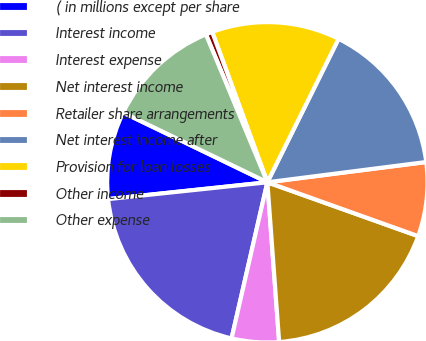Convert chart. <chart><loc_0><loc_0><loc_500><loc_500><pie_chart><fcel>( in millions except per share<fcel>Interest income<fcel>Interest expense<fcel>Net interest income<fcel>Retailer share arrangements<fcel>Net interest income after<fcel>Provision for loan losses<fcel>Other income<fcel>Other expense<nl><fcel>8.84%<fcel>19.74%<fcel>4.76%<fcel>18.37%<fcel>7.48%<fcel>15.65%<fcel>12.93%<fcel>0.67%<fcel>11.57%<nl></chart> 